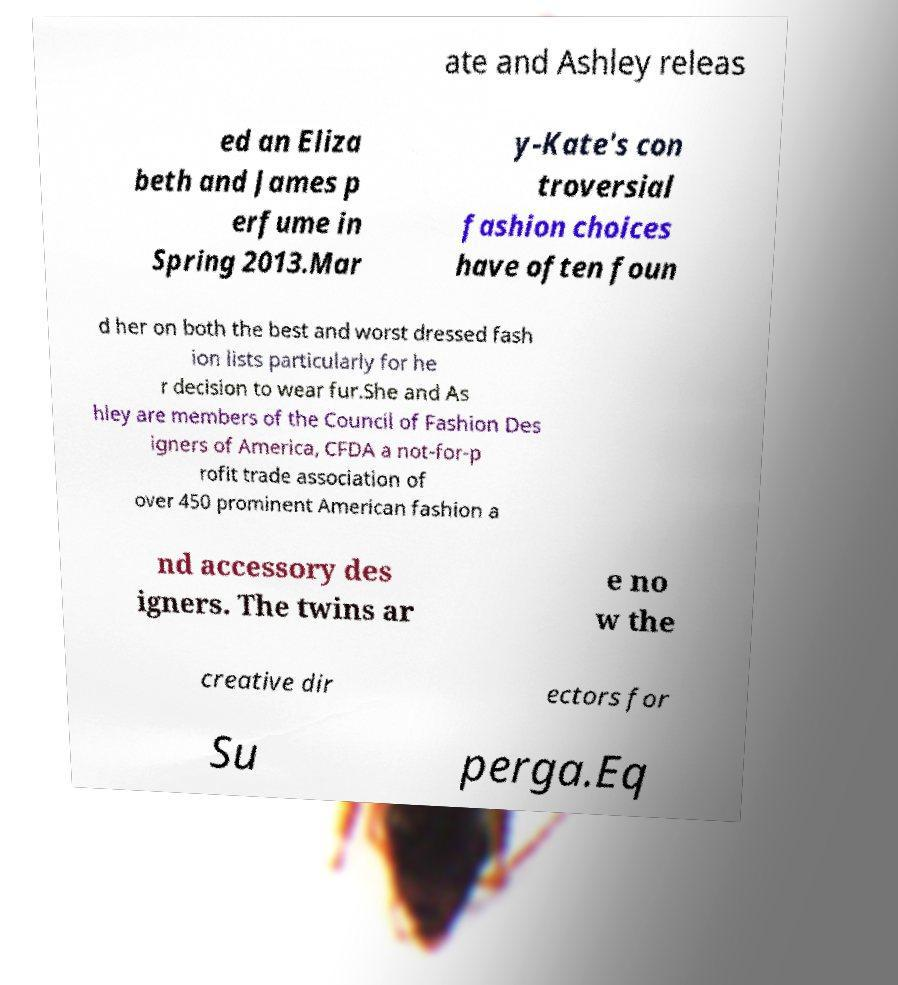Could you assist in decoding the text presented in this image and type it out clearly? ate and Ashley releas ed an Eliza beth and James p erfume in Spring 2013.Mar y-Kate's con troversial fashion choices have often foun d her on both the best and worst dressed fash ion lists particularly for he r decision to wear fur.She and As hley are members of the Council of Fashion Des igners of America, CFDA a not-for-p rofit trade association of over 450 prominent American fashion a nd accessory des igners. The twins ar e no w the creative dir ectors for Su perga.Eq 